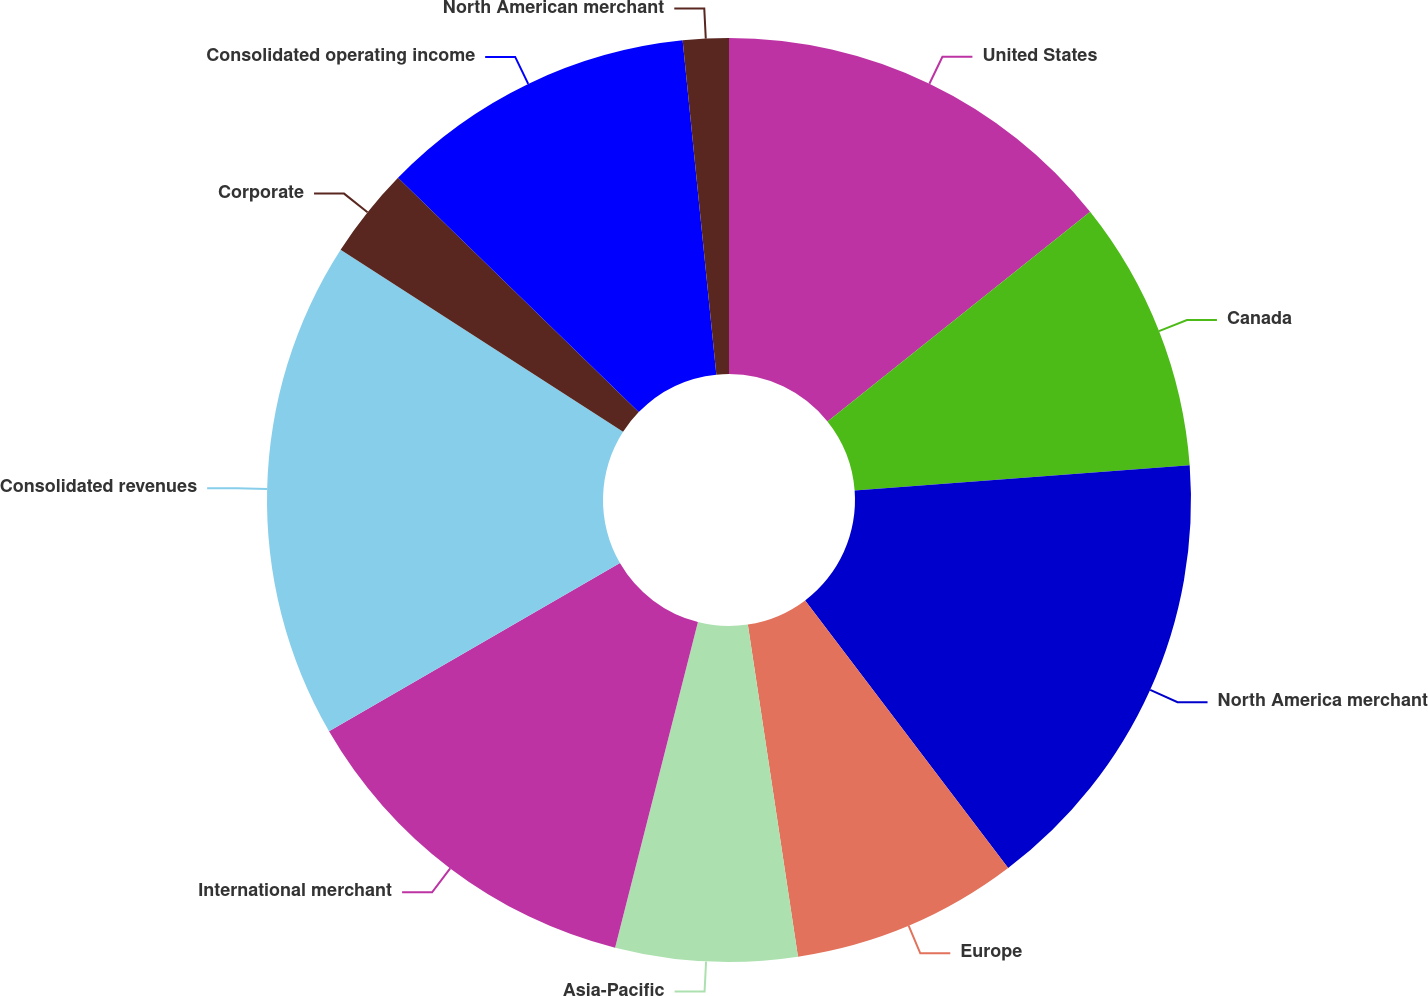Convert chart to OTSL. <chart><loc_0><loc_0><loc_500><loc_500><pie_chart><fcel>United States<fcel>Canada<fcel>North America merchant<fcel>Europe<fcel>Asia-Pacific<fcel>International merchant<fcel>Consolidated revenues<fcel>Corporate<fcel>Consolidated operating income<fcel>North American merchant<nl><fcel>14.28%<fcel>9.52%<fcel>15.87%<fcel>7.94%<fcel>6.35%<fcel>12.69%<fcel>17.45%<fcel>3.18%<fcel>11.11%<fcel>1.6%<nl></chart> 